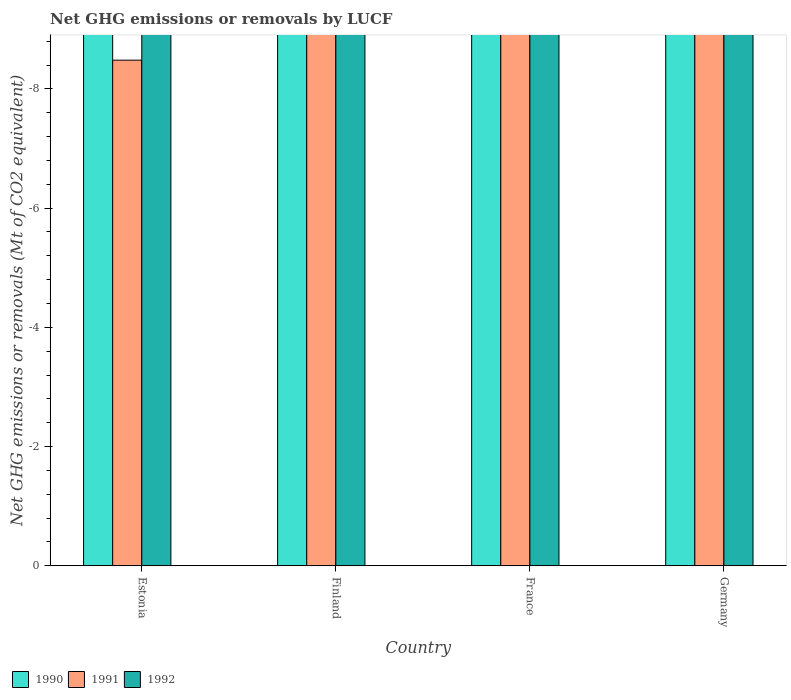How many bars are there on the 4th tick from the right?
Provide a succinct answer. 0. What is the net GHG emissions or removals by LUCF in 1990 in Germany?
Keep it short and to the point. 0. What is the difference between the net GHG emissions or removals by LUCF in 1990 in Germany and the net GHG emissions or removals by LUCF in 1992 in Estonia?
Provide a short and direct response. 0. In how many countries, is the net GHG emissions or removals by LUCF in 1991 greater than -8.8 Mt?
Offer a very short reply. 1. Is it the case that in every country, the sum of the net GHG emissions or removals by LUCF in 1990 and net GHG emissions or removals by LUCF in 1992 is greater than the net GHG emissions or removals by LUCF in 1991?
Offer a very short reply. No. How many countries are there in the graph?
Provide a short and direct response. 4. What is the difference between two consecutive major ticks on the Y-axis?
Ensure brevity in your answer.  2. Are the values on the major ticks of Y-axis written in scientific E-notation?
Ensure brevity in your answer.  No. Does the graph contain any zero values?
Offer a very short reply. Yes. How many legend labels are there?
Your response must be concise. 3. What is the title of the graph?
Ensure brevity in your answer.  Net GHG emissions or removals by LUCF. What is the label or title of the X-axis?
Keep it short and to the point. Country. What is the label or title of the Y-axis?
Give a very brief answer. Net GHG emissions or removals (Mt of CO2 equivalent). What is the Net GHG emissions or removals (Mt of CO2 equivalent) in 1991 in Estonia?
Offer a terse response. 0. What is the Net GHG emissions or removals (Mt of CO2 equivalent) of 1992 in Estonia?
Your response must be concise. 0. What is the Net GHG emissions or removals (Mt of CO2 equivalent) in 1990 in Finland?
Provide a short and direct response. 0. What is the Net GHG emissions or removals (Mt of CO2 equivalent) of 1991 in Finland?
Give a very brief answer. 0. What is the Net GHG emissions or removals (Mt of CO2 equivalent) of 1991 in Germany?
Give a very brief answer. 0. What is the Net GHG emissions or removals (Mt of CO2 equivalent) of 1992 in Germany?
Provide a short and direct response. 0. What is the total Net GHG emissions or removals (Mt of CO2 equivalent) in 1990 in the graph?
Your answer should be compact. 0. What is the total Net GHG emissions or removals (Mt of CO2 equivalent) in 1991 in the graph?
Keep it short and to the point. 0. What is the total Net GHG emissions or removals (Mt of CO2 equivalent) in 1992 in the graph?
Your response must be concise. 0. What is the average Net GHG emissions or removals (Mt of CO2 equivalent) of 1990 per country?
Keep it short and to the point. 0. What is the average Net GHG emissions or removals (Mt of CO2 equivalent) in 1991 per country?
Make the answer very short. 0. What is the average Net GHG emissions or removals (Mt of CO2 equivalent) in 1992 per country?
Offer a terse response. 0. 